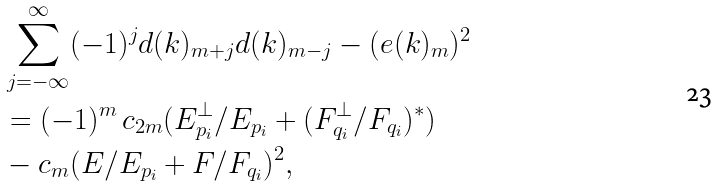Convert formula to latex. <formula><loc_0><loc_0><loc_500><loc_500>& \sum _ { j = - \infty } ^ { \infty } ( - 1 ) ^ { j } d ( k ) _ { m + j } d ( k ) _ { m - j } - ( e ( k ) _ { m } ) ^ { 2 } \\ & = ( - 1 ) ^ { m } \, c _ { 2 m } ( E _ { p _ { i } } ^ { \perp } / E _ { p _ { i } } + ( F _ { q _ { i } } ^ { \perp } / F _ { q _ { i } } ) ^ { * } ) \\ & - c _ { m } ( E / E _ { p _ { i } } + F / F _ { q _ { i } } ) ^ { 2 } ,</formula> 